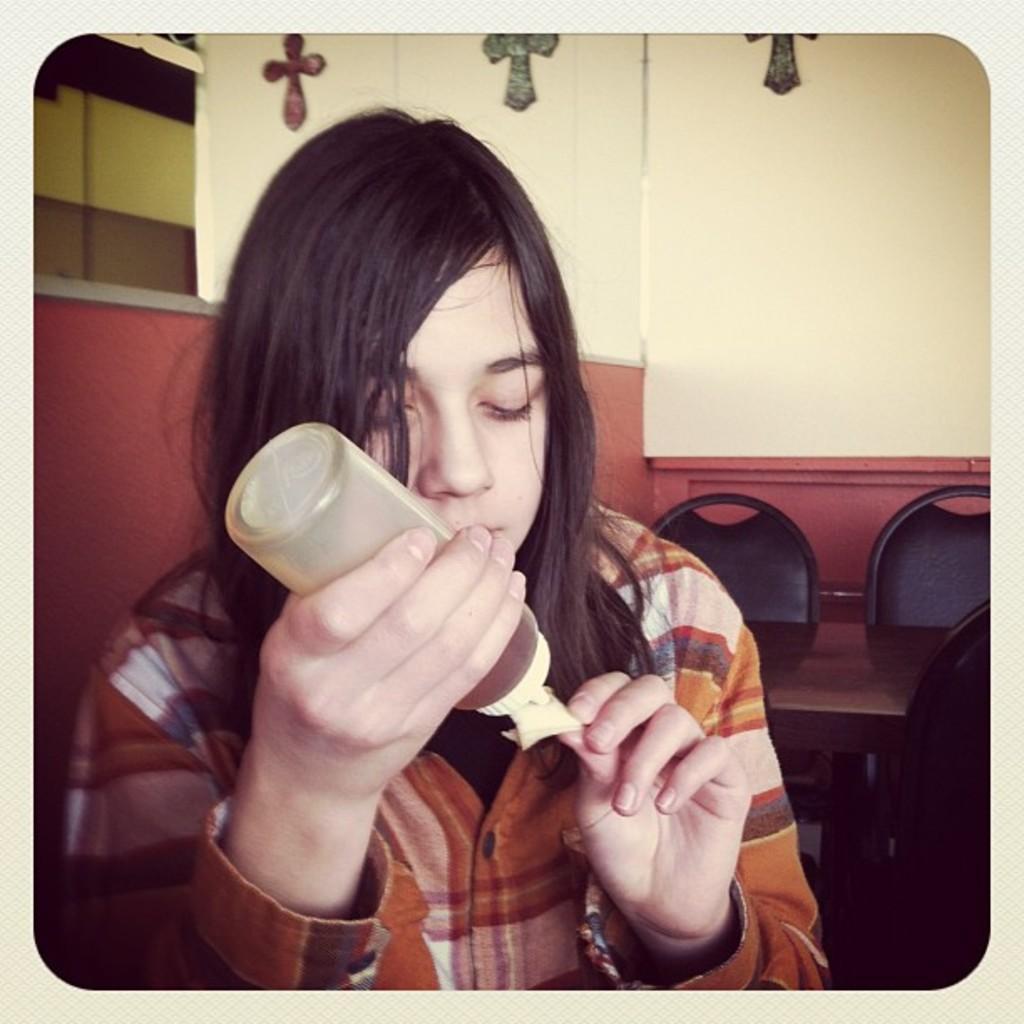In one or two sentences, can you explain what this image depicts? In the center of the image we can see a lady is present and holding a bottle in her hand. In the background of the image we can see a wall, chairs, table are present. 